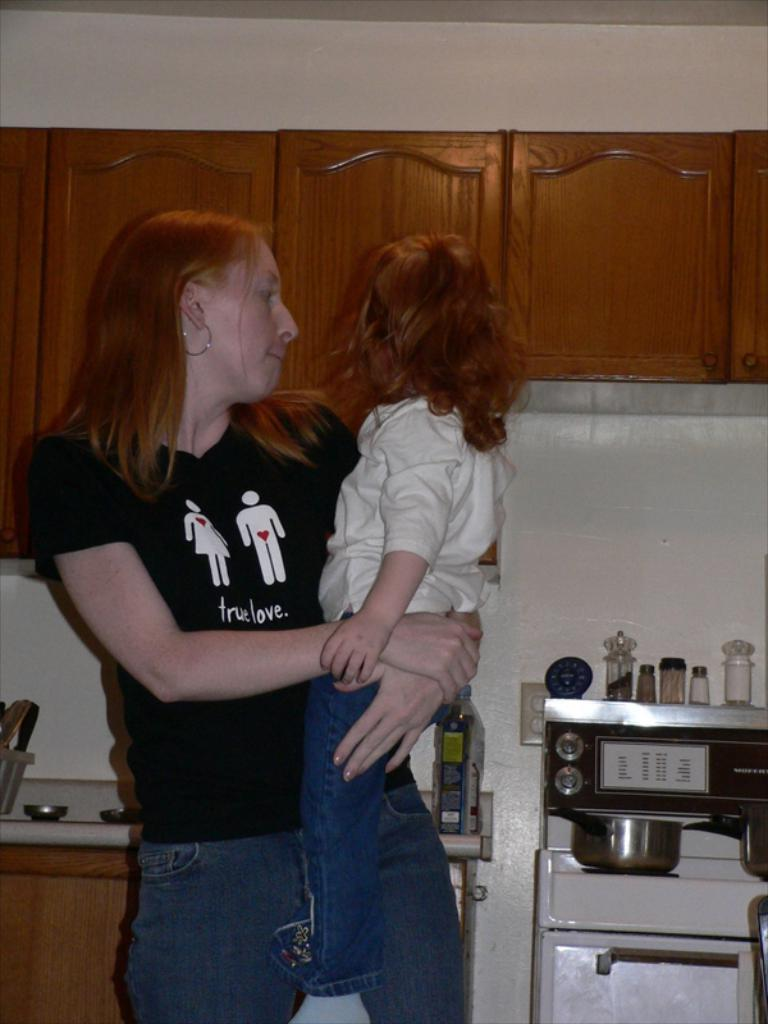<image>
Write a terse but informative summary of the picture. a lady with a shirt on that says true love 